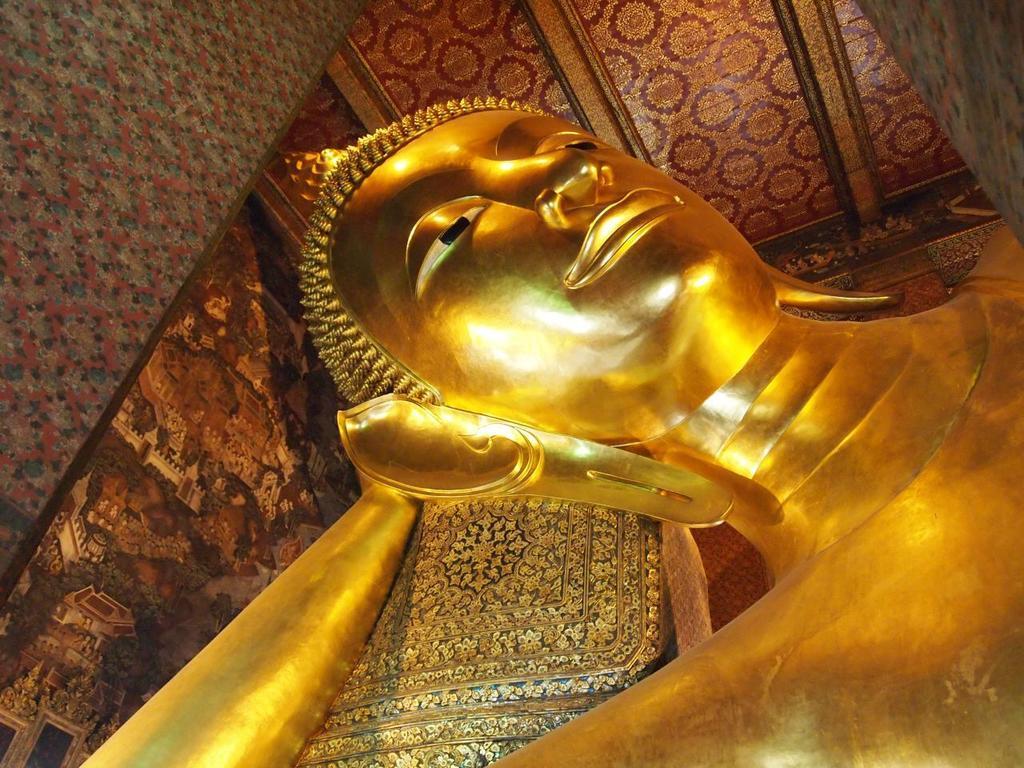Can you describe this image briefly? In the image there is a statue of buddha in the front and above its ceiling. 